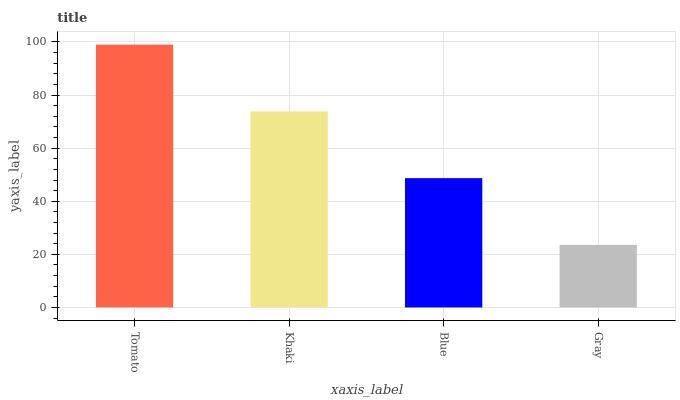Is Khaki the minimum?
Answer yes or no. No. Is Khaki the maximum?
Answer yes or no. No. Is Tomato greater than Khaki?
Answer yes or no. Yes. Is Khaki less than Tomato?
Answer yes or no. Yes. Is Khaki greater than Tomato?
Answer yes or no. No. Is Tomato less than Khaki?
Answer yes or no. No. Is Khaki the high median?
Answer yes or no. Yes. Is Blue the low median?
Answer yes or no. Yes. Is Gray the high median?
Answer yes or no. No. Is Gray the low median?
Answer yes or no. No. 